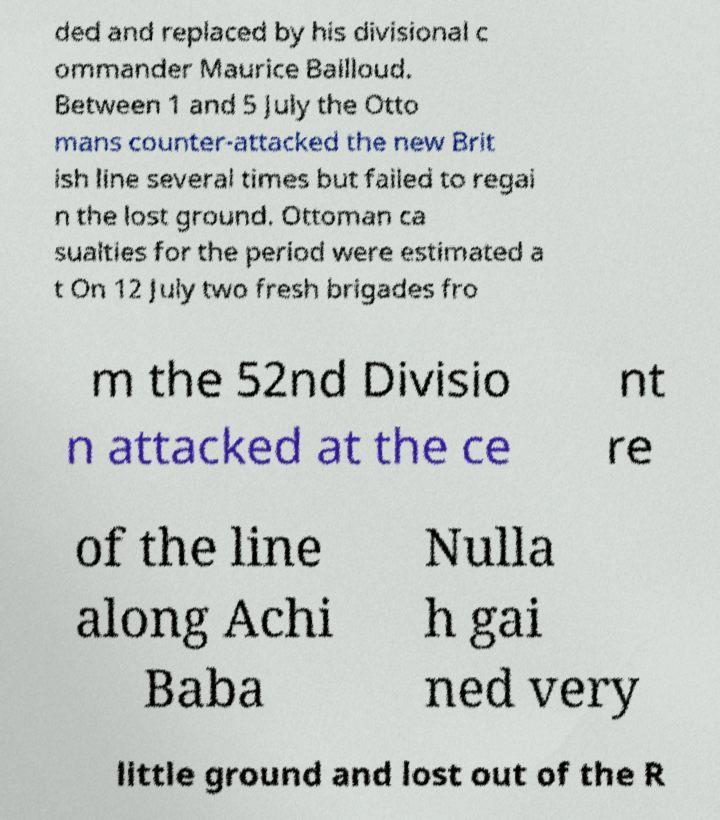Could you assist in decoding the text presented in this image and type it out clearly? ded and replaced by his divisional c ommander Maurice Bailloud. Between 1 and 5 July the Otto mans counter-attacked the new Brit ish line several times but failed to regai n the lost ground. Ottoman ca sualties for the period were estimated a t On 12 July two fresh brigades fro m the 52nd Divisio n attacked at the ce nt re of the line along Achi Baba Nulla h gai ned very little ground and lost out of the R 